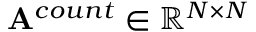Convert formula to latex. <formula><loc_0><loc_0><loc_500><loc_500>A ^ { c o u n t } \in \mathbb { R } ^ { N \times N }</formula> 